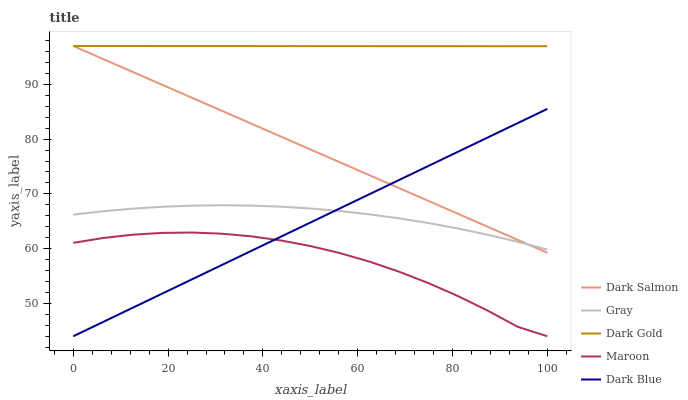Does Maroon have the minimum area under the curve?
Answer yes or no. Yes. Does Dark Gold have the maximum area under the curve?
Answer yes or no. Yes. Does Dark Blue have the minimum area under the curve?
Answer yes or no. No. Does Dark Blue have the maximum area under the curve?
Answer yes or no. No. Is Dark Blue the smoothest?
Answer yes or no. Yes. Is Maroon the roughest?
Answer yes or no. Yes. Is Dark Salmon the smoothest?
Answer yes or no. No. Is Dark Salmon the roughest?
Answer yes or no. No. Does Dark Blue have the lowest value?
Answer yes or no. Yes. Does Dark Salmon have the lowest value?
Answer yes or no. No. Does Dark Gold have the highest value?
Answer yes or no. Yes. Does Dark Blue have the highest value?
Answer yes or no. No. Is Maroon less than Dark Salmon?
Answer yes or no. Yes. Is Dark Gold greater than Gray?
Answer yes or no. Yes. Does Maroon intersect Dark Blue?
Answer yes or no. Yes. Is Maroon less than Dark Blue?
Answer yes or no. No. Is Maroon greater than Dark Blue?
Answer yes or no. No. Does Maroon intersect Dark Salmon?
Answer yes or no. No. 